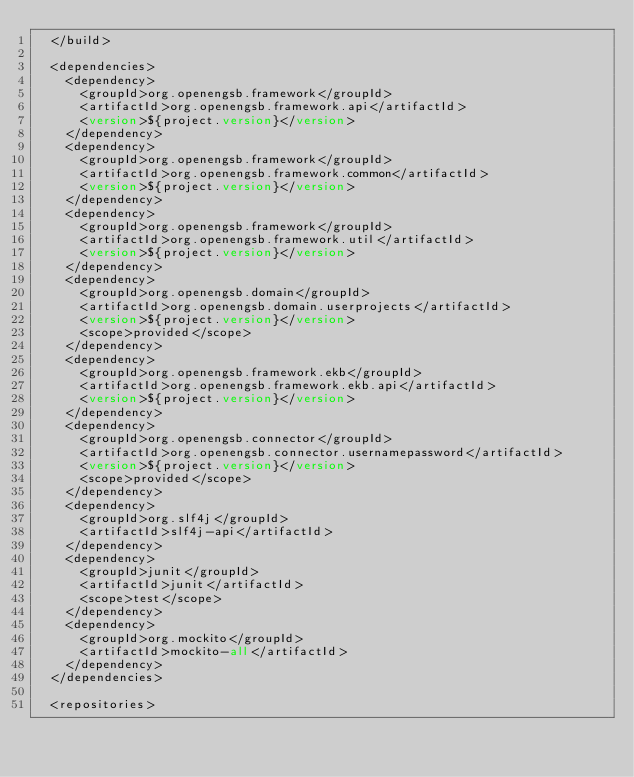<code> <loc_0><loc_0><loc_500><loc_500><_XML_>  </build>

  <dependencies>
    <dependency>
      <groupId>org.openengsb.framework</groupId>
      <artifactId>org.openengsb.framework.api</artifactId>
      <version>${project.version}</version>
    </dependency>
    <dependency>
      <groupId>org.openengsb.framework</groupId>
      <artifactId>org.openengsb.framework.common</artifactId>
      <version>${project.version}</version>
    </dependency>
    <dependency>
      <groupId>org.openengsb.framework</groupId>
      <artifactId>org.openengsb.framework.util</artifactId>
      <version>${project.version}</version>
    </dependency>
    <dependency>
      <groupId>org.openengsb.domain</groupId>
      <artifactId>org.openengsb.domain.userprojects</artifactId>
      <version>${project.version}</version>
      <scope>provided</scope>
    </dependency>
    <dependency>
      <groupId>org.openengsb.framework.ekb</groupId>
      <artifactId>org.openengsb.framework.ekb.api</artifactId>
      <version>${project.version}</version>
    </dependency>
    <dependency>
      <groupId>org.openengsb.connector</groupId>
      <artifactId>org.openengsb.connector.usernamepassword</artifactId>
      <version>${project.version}</version>
      <scope>provided</scope>
    </dependency>
    <dependency>
      <groupId>org.slf4j</groupId>
      <artifactId>slf4j-api</artifactId>
    </dependency>
    <dependency>
      <groupId>junit</groupId>
      <artifactId>junit</artifactId>
      <scope>test</scope>
    </dependency>
    <dependency>
      <groupId>org.mockito</groupId>
      <artifactId>mockito-all</artifactId>
    </dependency>
  </dependencies>

  <repositories></code> 